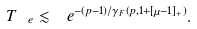<formula> <loc_0><loc_0><loc_500><loc_500>T _ { \ e } \lesssim \ e ^ { - ( p - 1 ) / \gamma _ { F } \left ( p , 1 + [ \mu - 1 ] _ { + } \right ) } .</formula> 